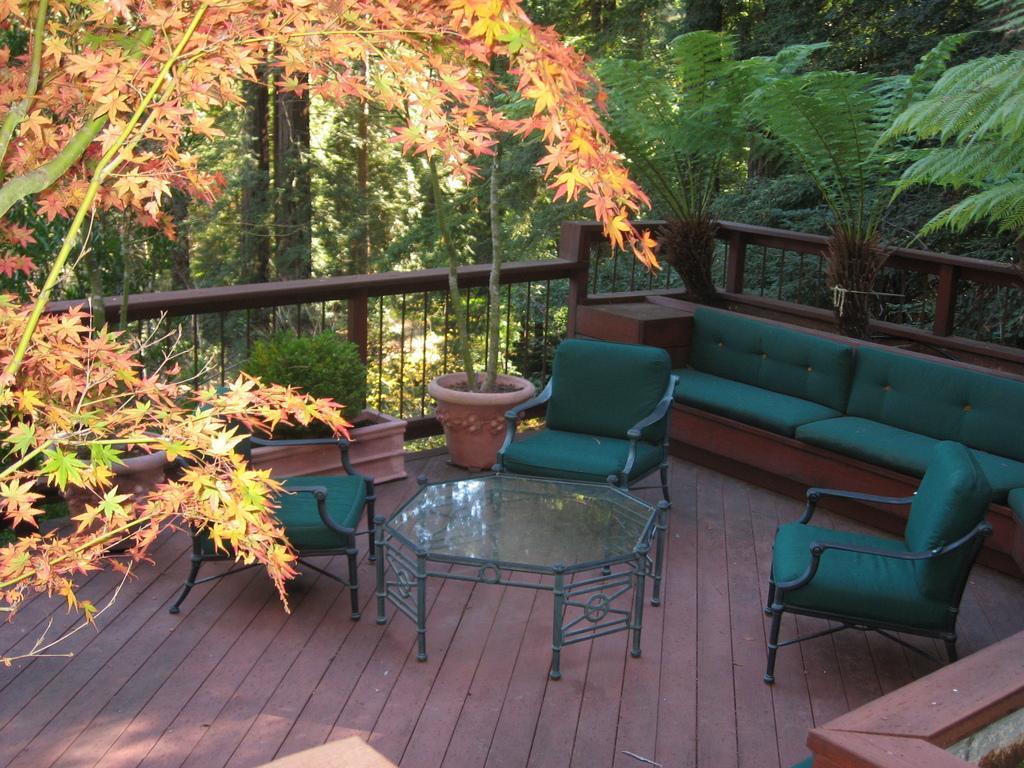In one or two sentences, can you explain what this image depicts? This image consists of trees on both side. In the middle and bottom there is a balcony, in which table and chairs are kept and house plant is there. This image is taken during day time in a sunny day. 